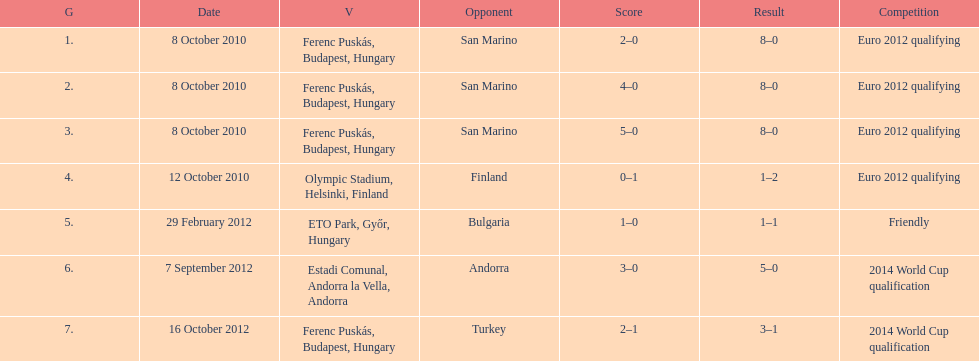How many non-qualifying games did he score in? 1. 